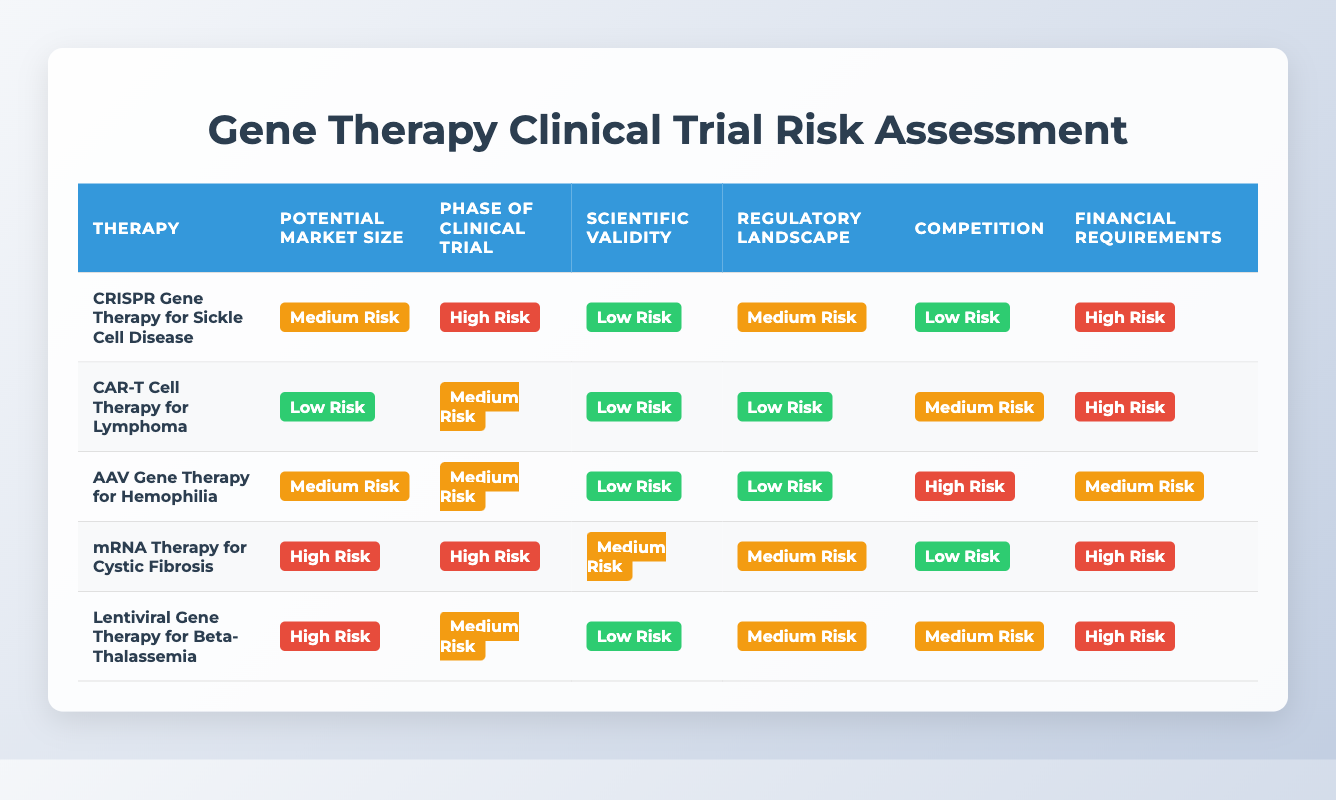What is the risk level for the Potential Market Size of AAV Gene Therapy for Hemophilia? The risk level for the Potential Market Size of AAV Gene Therapy for Hemophilia is found directly in the table under the "Potential Market Size" column for that therapy, which states "Medium Risk."
Answer: Medium Risk Which therapy has the highest risk in the Phase of Clinical Trial? Looking at the "Phase of Clinical Trial" column, both CRISPR Gene Therapy for Sickle Cell Disease and mRNA Therapy for Cystic Fibrosis have a risk level of "High Risk," making them the therapies with the highest risk in that category.
Answer: CRISPR Gene Therapy for Sickle Cell Disease, mRNA Therapy for Cystic Fibrosis Is the competition for CAR-T Cell Therapy for Lymphoma low risk? Referring to the "Competition" column for CAR-T Cell Therapy for Lymphoma, it shows "Medium Risk," therefore the statement is false.
Answer: No What is the average risk level of Financial Requirements across all therapies listed? To find the average risk level, we convert each risk level to a numeric scale: Low Risk = 1, Medium Risk = 2, High Risk = 3. The Financial Requirements values are High Risk (3), High Risk (3), Medium Risk (2), High Risk (3), and High Risk (3). The total is 14, with 5 entries, so the average is 14/5 = 2.8, which corresponds to Medium Risk.
Answer: Medium Risk Which therapy has the lowest risk level in Scientific Validity? In the "Scientific Validity" column, all therapies are assessed. The lowest risk identified is "Low Risk," which is present for CRISPR Gene Therapy for Sickle Cell Disease, CAR-T Cell Therapy for Lymphoma, AAV Gene Therapy for Hemophilia, and Lentiviral Gene Therapy for Beta-Thalassemia.
Answer: CRISPR Gene Therapy for Sickle Cell Disease, CAR-T Cell Therapy for Lymphoma, AAV Gene Therapy for Hemophilia, Lentiviral Gene Therapy for Beta-Thalassemia How many therapies have a financial requirement categorized as High Risk? In the "Financial Requirements" column, by counting the "High Risk" entries for each therapy, we find that there are four therapies listed as "High Risk." Specifically, CRISPR Gene Therapy for Sickle Cell Disease, CAR-T Cell Therapy for Lymphoma, mRNA Therapy for Cystic Fibrosis, and Lentiviral Gene Therapy for Beta-Thalassemia.
Answer: 4 Is there a therapy that has high risk across all categories? Examining the table reveals no therapy with "High Risk" in all categories. The maximum high risk appears only in specific categories for each therapy, but not all categories for any one therapy.
Answer: No 